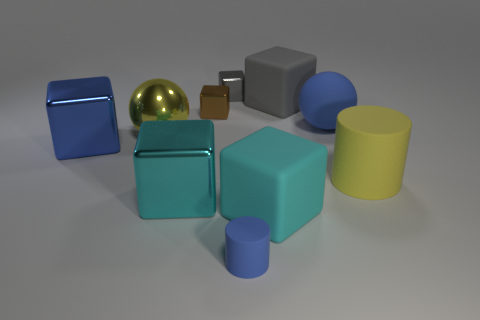There is another large metal thing that is the same shape as the big cyan shiny thing; what color is it?
Offer a very short reply. Blue. Are there fewer cyan objects right of the gray matte block than small brown cubes that are in front of the yellow matte cylinder?
Make the answer very short. No. How many other objects are the same shape as the big yellow matte object?
Provide a succinct answer. 1. Is the number of small metallic blocks that are to the left of the large gray thing less than the number of brown metal things?
Offer a very short reply. No. What material is the yellow thing that is to the right of the large cyan matte object?
Give a very brief answer. Rubber. What number of other objects are the same size as the metal sphere?
Offer a terse response. 6. Are there fewer gray metal blocks than large brown matte cylinders?
Provide a succinct answer. No. What is the shape of the cyan metal thing?
Provide a succinct answer. Cube. Do the block that is to the right of the large cyan matte cube and the metallic ball have the same color?
Keep it short and to the point. No. What is the shape of the metal thing that is in front of the tiny gray object and to the right of the big cyan metallic block?
Give a very brief answer. Cube. 